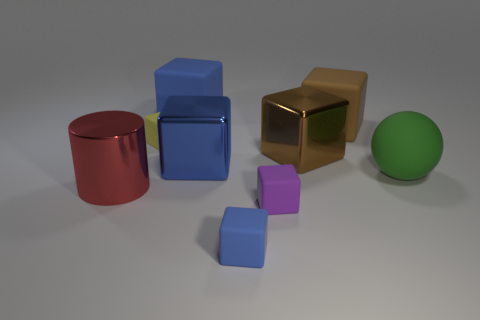Subtract all blue blocks. How many were subtracted if there are1blue blocks left? 2 Subtract all big blue shiny blocks. How many blocks are left? 6 Subtract all cylinders. How many objects are left? 8 Subtract 5 blocks. How many blocks are left? 2 Subtract all blue blocks. How many blocks are left? 4 Add 6 big rubber things. How many big rubber things exist? 9 Add 1 red matte objects. How many objects exist? 10 Subtract 1 blue blocks. How many objects are left? 8 Subtract all gray balls. Subtract all yellow cubes. How many balls are left? 1 Subtract all yellow cylinders. How many purple spheres are left? 0 